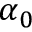Convert formula to latex. <formula><loc_0><loc_0><loc_500><loc_500>\alpha _ { 0 }</formula> 